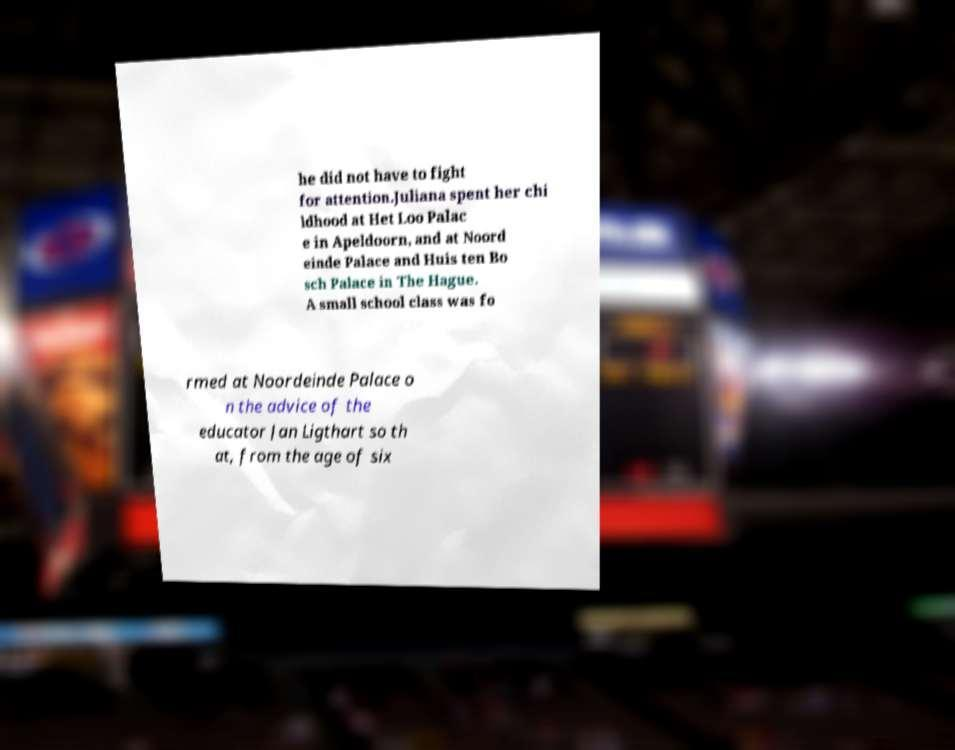Please read and relay the text visible in this image. What does it say? he did not have to fight for attention.Juliana spent her chi ldhood at Het Loo Palac e in Apeldoorn, and at Noord einde Palace and Huis ten Bo sch Palace in The Hague. A small school class was fo rmed at Noordeinde Palace o n the advice of the educator Jan Ligthart so th at, from the age of six 